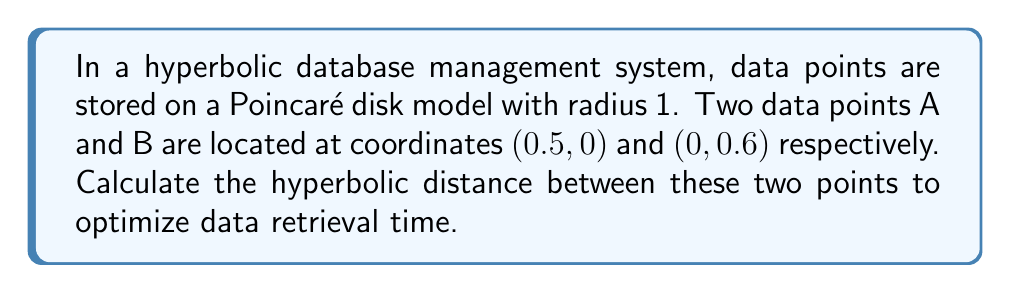Can you answer this question? To solve this problem, we'll follow these steps:

1) In the Poincaré disk model, the hyperbolic distance $d$ between two points $(x_1, y_1)$ and $(x_2, y_2)$ is given by the formula:

   $$d = \text{arcosh}\left(1 + \frac{2|z_1 - z_2|^2}{(1 - |z_1|^2)(1 - |z_2|^2)}\right)$$

   where $z_1 = x_1 + iy_1$ and $z_2 = x_2 + iy_2$ are the complex representations of the points.

2) For our points:
   A: $z_1 = 0.5 + 0i = 0.5$
   B: $z_2 = 0 + 0.6i = 0.6i$

3) Calculate $|z_1 - z_2|^2$:
   $$|z_1 - z_2|^2 = |0.5 - 0.6i|^2 = 0.5^2 + 0.6^2 = 0.61$$

4) Calculate $(1 - |z_1|^2)(1 - |z_2|^2)$:
   $$(1 - |0.5|^2)(1 - |0.6i|^2) = (1 - 0.25)(1 - 0.36) = 0.75 \times 0.64 = 0.48$$

5) Now, let's substitute these values into our distance formula:

   $$d = \text{arcosh}\left(1 + \frac{2 \times 0.61}{0.48}\right)$$

6) Simplify:
   $$d = \text{arcosh}\left(1 + 2.5416\right) = \text{arcosh}(3.5416)$$

7) Calculate the final result:
   $$d \approx 1.9043$$

This hyperbolic distance can be used to optimize data retrieval time in the database management system.
Answer: $\text{arcosh}(3.5416) \approx 1.9043$ 